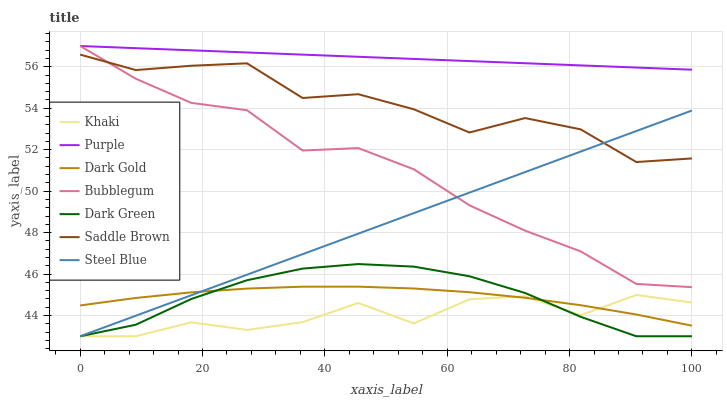Does Khaki have the minimum area under the curve?
Answer yes or no. Yes. Does Purple have the maximum area under the curve?
Answer yes or no. Yes. Does Dark Gold have the minimum area under the curve?
Answer yes or no. No. Does Dark Gold have the maximum area under the curve?
Answer yes or no. No. Is Purple the smoothest?
Answer yes or no. Yes. Is Khaki the roughest?
Answer yes or no. Yes. Is Dark Gold the smoothest?
Answer yes or no. No. Is Dark Gold the roughest?
Answer yes or no. No. Does Dark Gold have the lowest value?
Answer yes or no. No. Does Bubblegum have the highest value?
Answer yes or no. Yes. Does Dark Gold have the highest value?
Answer yes or no. No. Is Dark Gold less than Bubblegum?
Answer yes or no. Yes. Is Saddle Brown greater than Khaki?
Answer yes or no. Yes. Does Steel Blue intersect Khaki?
Answer yes or no. Yes. Is Steel Blue less than Khaki?
Answer yes or no. No. Is Steel Blue greater than Khaki?
Answer yes or no. No. Does Dark Gold intersect Bubblegum?
Answer yes or no. No. 